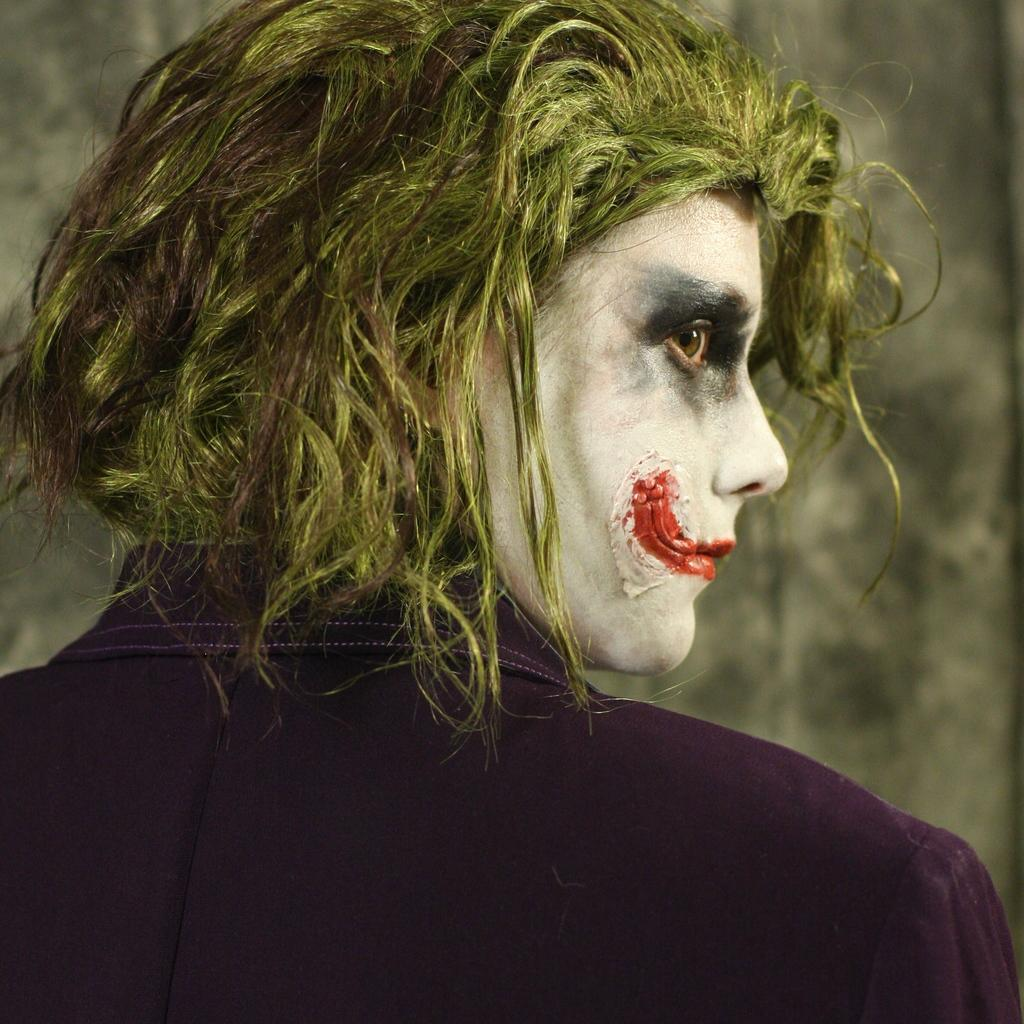Who is present in the image? There is a man in the image. What is the man wearing? The man is wearing a joker's costume and a purple color coat. What can be seen in the background of the image? There is a wall in the background of the image. What type of cork can be seen in the man's hand in the image? There is no cork present in the man's hand or anywhere in the image. 